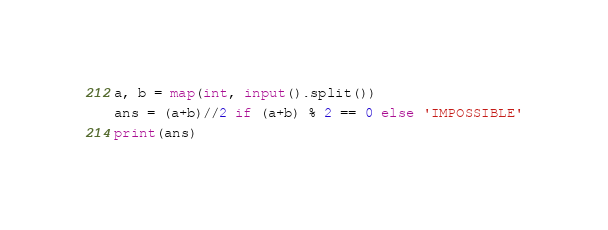Convert code to text. <code><loc_0><loc_0><loc_500><loc_500><_Python_>a, b = map(int, input().split())
ans = (a+b)//2 if (a+b) % 2 == 0 else 'IMPOSSIBLE'
print(ans)
</code> 